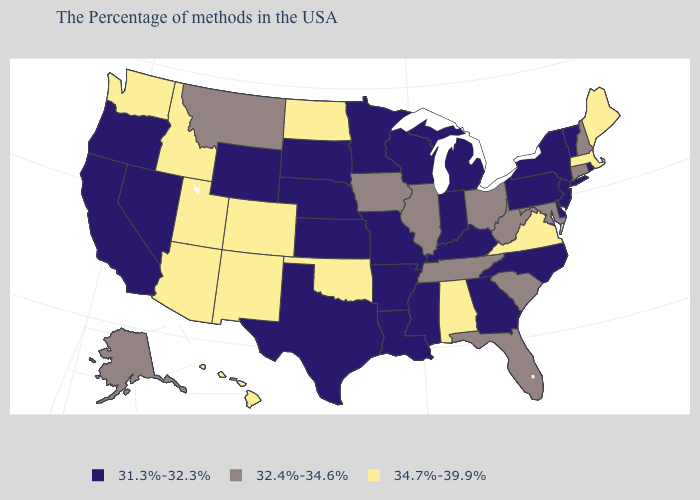Name the states that have a value in the range 31.3%-32.3%?
Keep it brief. Rhode Island, Vermont, New York, New Jersey, Delaware, Pennsylvania, North Carolina, Georgia, Michigan, Kentucky, Indiana, Wisconsin, Mississippi, Louisiana, Missouri, Arkansas, Minnesota, Kansas, Nebraska, Texas, South Dakota, Wyoming, Nevada, California, Oregon. Name the states that have a value in the range 32.4%-34.6%?
Write a very short answer. New Hampshire, Connecticut, Maryland, South Carolina, West Virginia, Ohio, Florida, Tennessee, Illinois, Iowa, Montana, Alaska. How many symbols are there in the legend?
Give a very brief answer. 3. Does the map have missing data?
Quick response, please. No. Among the states that border Minnesota , which have the lowest value?
Quick response, please. Wisconsin, South Dakota. What is the value of Wyoming?
Give a very brief answer. 31.3%-32.3%. What is the value of Arkansas?
Short answer required. 31.3%-32.3%. Does South Carolina have the highest value in the South?
Write a very short answer. No. What is the value of New Jersey?
Write a very short answer. 31.3%-32.3%. Among the states that border Tennessee , which have the highest value?
Write a very short answer. Virginia, Alabama. Does Mississippi have the same value as New Mexico?
Be succinct. No. What is the lowest value in the Northeast?
Concise answer only. 31.3%-32.3%. Does New Mexico have the highest value in the USA?
Write a very short answer. Yes. Does New Jersey have a lower value than North Carolina?
Concise answer only. No. What is the lowest value in the MidWest?
Keep it brief. 31.3%-32.3%. 